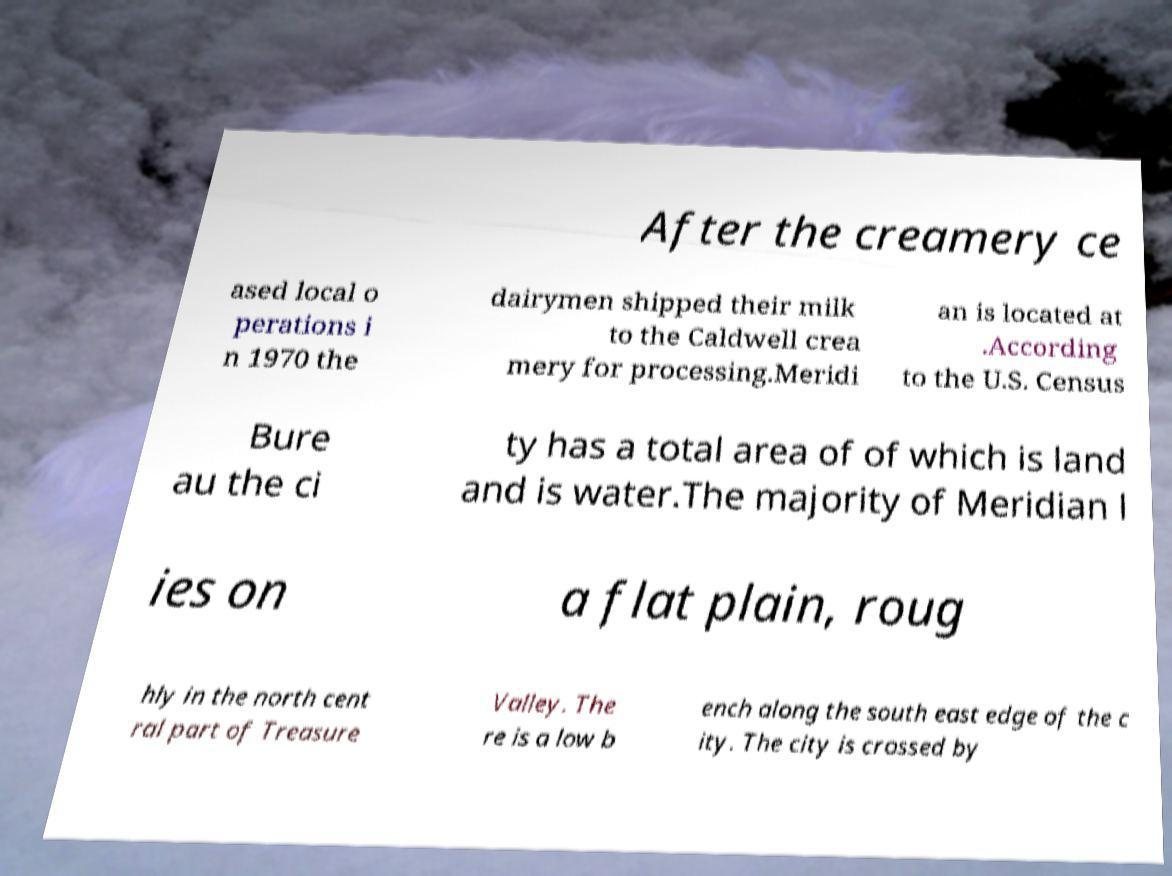Please read and relay the text visible in this image. What does it say? After the creamery ce ased local o perations i n 1970 the dairymen shipped their milk to the Caldwell crea mery for processing.Meridi an is located at .According to the U.S. Census Bure au the ci ty has a total area of of which is land and is water.The majority of Meridian l ies on a flat plain, roug hly in the north cent ral part of Treasure Valley. The re is a low b ench along the south east edge of the c ity. The city is crossed by 